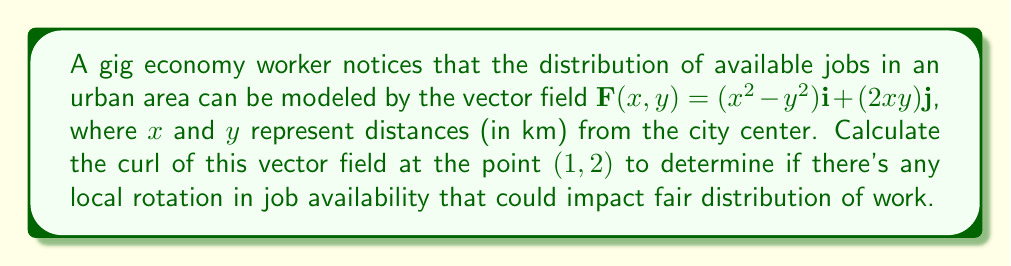Can you solve this math problem? To solve this problem, we need to follow these steps:

1) The curl of a vector field $\mathbf{F}(x,y) = P(x,y)\mathbf{i} + Q(x,y)\mathbf{j}$ in two dimensions is given by:

   $$\text{curl }\mathbf{F} = \nabla \times \mathbf{F} = \left(\frac{\partial Q}{\partial x} - \frac{\partial P}{\partial y}\right)\mathbf{k}$$

2) In our case, $P(x,y) = x^2 - y^2$ and $Q(x,y) = 2xy$

3) Let's calculate the partial derivatives:

   $\frac{\partial Q}{\partial x} = \frac{\partial}{\partial x}(2xy) = 2y$

   $\frac{\partial P}{\partial y} = \frac{\partial}{\partial y}(x^2 - y^2) = -2y$

4) Now, we can substitute these into the curl formula:

   $$\text{curl }\mathbf{F} = (2y - (-2y))\mathbf{k} = 4y\mathbf{k}$$

5) To find the curl at the point (1, 2), we simply substitute y = 2:

   $$\text{curl }\mathbf{F}(1,2) = 4(2)\mathbf{k} = 8\mathbf{k}$$

The non-zero curl indicates that there is indeed local rotation in the job availability field at the point (1, 2), which could potentially lead to unfair distribution of work opportunities.
Answer: $8\mathbf{k}$ 